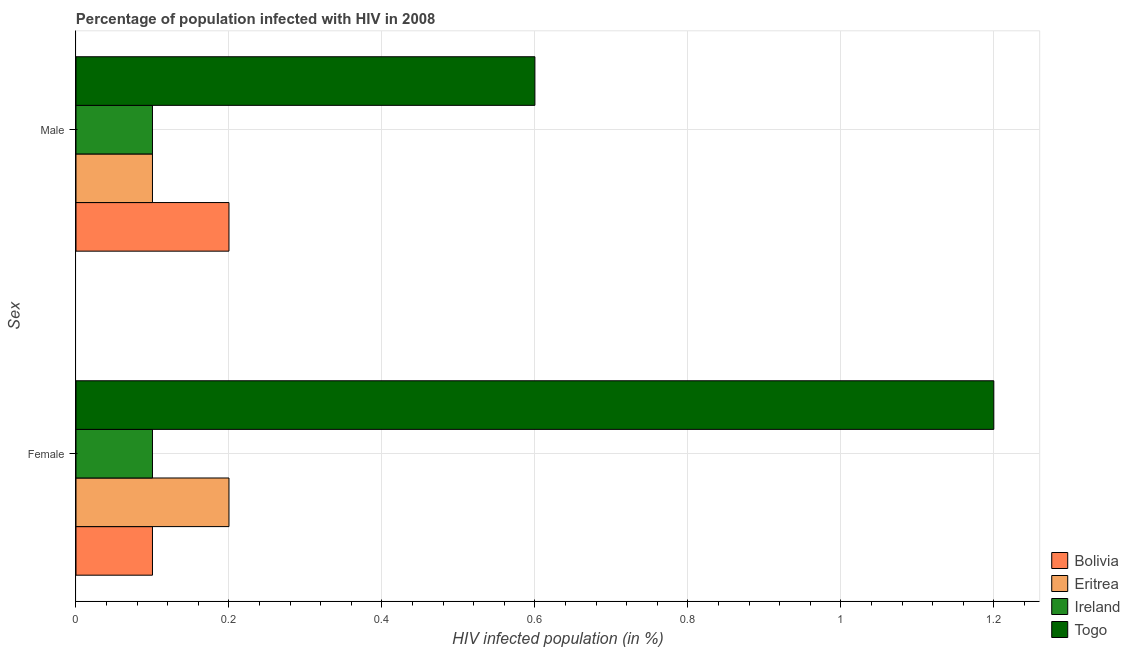How many groups of bars are there?
Offer a terse response. 2. Are the number of bars on each tick of the Y-axis equal?
Give a very brief answer. Yes. How many bars are there on the 1st tick from the top?
Keep it short and to the point. 4. How many bars are there on the 2nd tick from the bottom?
Your answer should be very brief. 4. What is the label of the 2nd group of bars from the top?
Give a very brief answer. Female. What is the percentage of females who are infected with hiv in Togo?
Offer a terse response. 1.2. In which country was the percentage of females who are infected with hiv maximum?
Your answer should be very brief. Togo. In which country was the percentage of males who are infected with hiv minimum?
Offer a terse response. Eritrea. What is the difference between the percentage of females who are infected with hiv in Togo and that in Eritrea?
Your response must be concise. 1. What is the difference between the percentage of males who are infected with hiv in Bolivia and the percentage of females who are infected with hiv in Eritrea?
Your answer should be very brief. 0. What is the average percentage of males who are infected with hiv per country?
Provide a short and direct response. 0.25. What is the difference between the percentage of females who are infected with hiv and percentage of males who are infected with hiv in Ireland?
Your answer should be very brief. 0. What is the ratio of the percentage of females who are infected with hiv in Togo to that in Eritrea?
Give a very brief answer. 6. What does the 3rd bar from the top in Female represents?
Your answer should be very brief. Eritrea. What does the 4th bar from the bottom in Female represents?
Provide a succinct answer. Togo. How many bars are there?
Make the answer very short. 8. Are all the bars in the graph horizontal?
Your answer should be very brief. Yes. How many countries are there in the graph?
Offer a very short reply. 4. Where does the legend appear in the graph?
Make the answer very short. Bottom right. How many legend labels are there?
Give a very brief answer. 4. How are the legend labels stacked?
Give a very brief answer. Vertical. What is the title of the graph?
Provide a succinct answer. Percentage of population infected with HIV in 2008. What is the label or title of the X-axis?
Your answer should be very brief. HIV infected population (in %). What is the label or title of the Y-axis?
Give a very brief answer. Sex. What is the HIV infected population (in %) of Eritrea in Female?
Your answer should be compact. 0.2. What is the HIV infected population (in %) of Ireland in Female?
Your response must be concise. 0.1. What is the HIV infected population (in %) of Togo in Female?
Make the answer very short. 1.2. What is the HIV infected population (in %) in Bolivia in Male?
Your response must be concise. 0.2. What is the HIV infected population (in %) in Eritrea in Male?
Give a very brief answer. 0.1. Across all Sex, what is the maximum HIV infected population (in %) of Ireland?
Provide a short and direct response. 0.1. Across all Sex, what is the maximum HIV infected population (in %) of Togo?
Make the answer very short. 1.2. Across all Sex, what is the minimum HIV infected population (in %) of Ireland?
Your answer should be compact. 0.1. Across all Sex, what is the minimum HIV infected population (in %) of Togo?
Give a very brief answer. 0.6. What is the total HIV infected population (in %) in Eritrea in the graph?
Provide a short and direct response. 0.3. What is the difference between the HIV infected population (in %) of Eritrea in Female and that in Male?
Provide a short and direct response. 0.1. What is the difference between the HIV infected population (in %) in Ireland in Female and that in Male?
Provide a short and direct response. 0. What is the difference between the HIV infected population (in %) in Togo in Female and that in Male?
Ensure brevity in your answer.  0.6. What is the difference between the HIV infected population (in %) of Bolivia in Female and the HIV infected population (in %) of Eritrea in Male?
Your answer should be compact. 0. What is the difference between the HIV infected population (in %) of Bolivia in Female and the HIV infected population (in %) of Togo in Male?
Make the answer very short. -0.5. What is the difference between the HIV infected population (in %) in Eritrea in Female and the HIV infected population (in %) in Ireland in Male?
Keep it short and to the point. 0.1. What is the difference between the HIV infected population (in %) of Ireland in Female and the HIV infected population (in %) of Togo in Male?
Provide a succinct answer. -0.5. What is the average HIV infected population (in %) of Bolivia per Sex?
Your answer should be compact. 0.15. What is the average HIV infected population (in %) in Ireland per Sex?
Provide a short and direct response. 0.1. What is the difference between the HIV infected population (in %) of Eritrea and HIV infected population (in %) of Togo in Female?
Offer a very short reply. -1. What is the difference between the HIV infected population (in %) in Eritrea and HIV infected population (in %) in Ireland in Male?
Your response must be concise. 0. What is the ratio of the HIV infected population (in %) of Togo in Female to that in Male?
Provide a succinct answer. 2. What is the difference between the highest and the second highest HIV infected population (in %) of Bolivia?
Ensure brevity in your answer.  0.1. What is the difference between the highest and the second highest HIV infected population (in %) of Eritrea?
Provide a succinct answer. 0.1. What is the difference between the highest and the lowest HIV infected population (in %) in Bolivia?
Give a very brief answer. 0.1. What is the difference between the highest and the lowest HIV infected population (in %) of Eritrea?
Keep it short and to the point. 0.1. What is the difference between the highest and the lowest HIV infected population (in %) in Ireland?
Give a very brief answer. 0. 